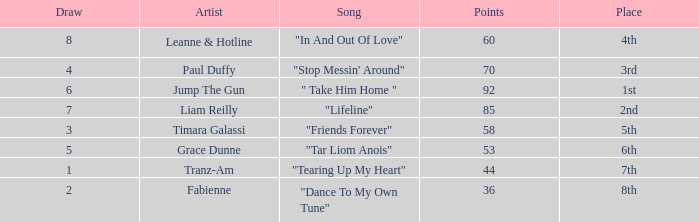What's the average amount of points for "in and out of love" with a draw over 8? None. 